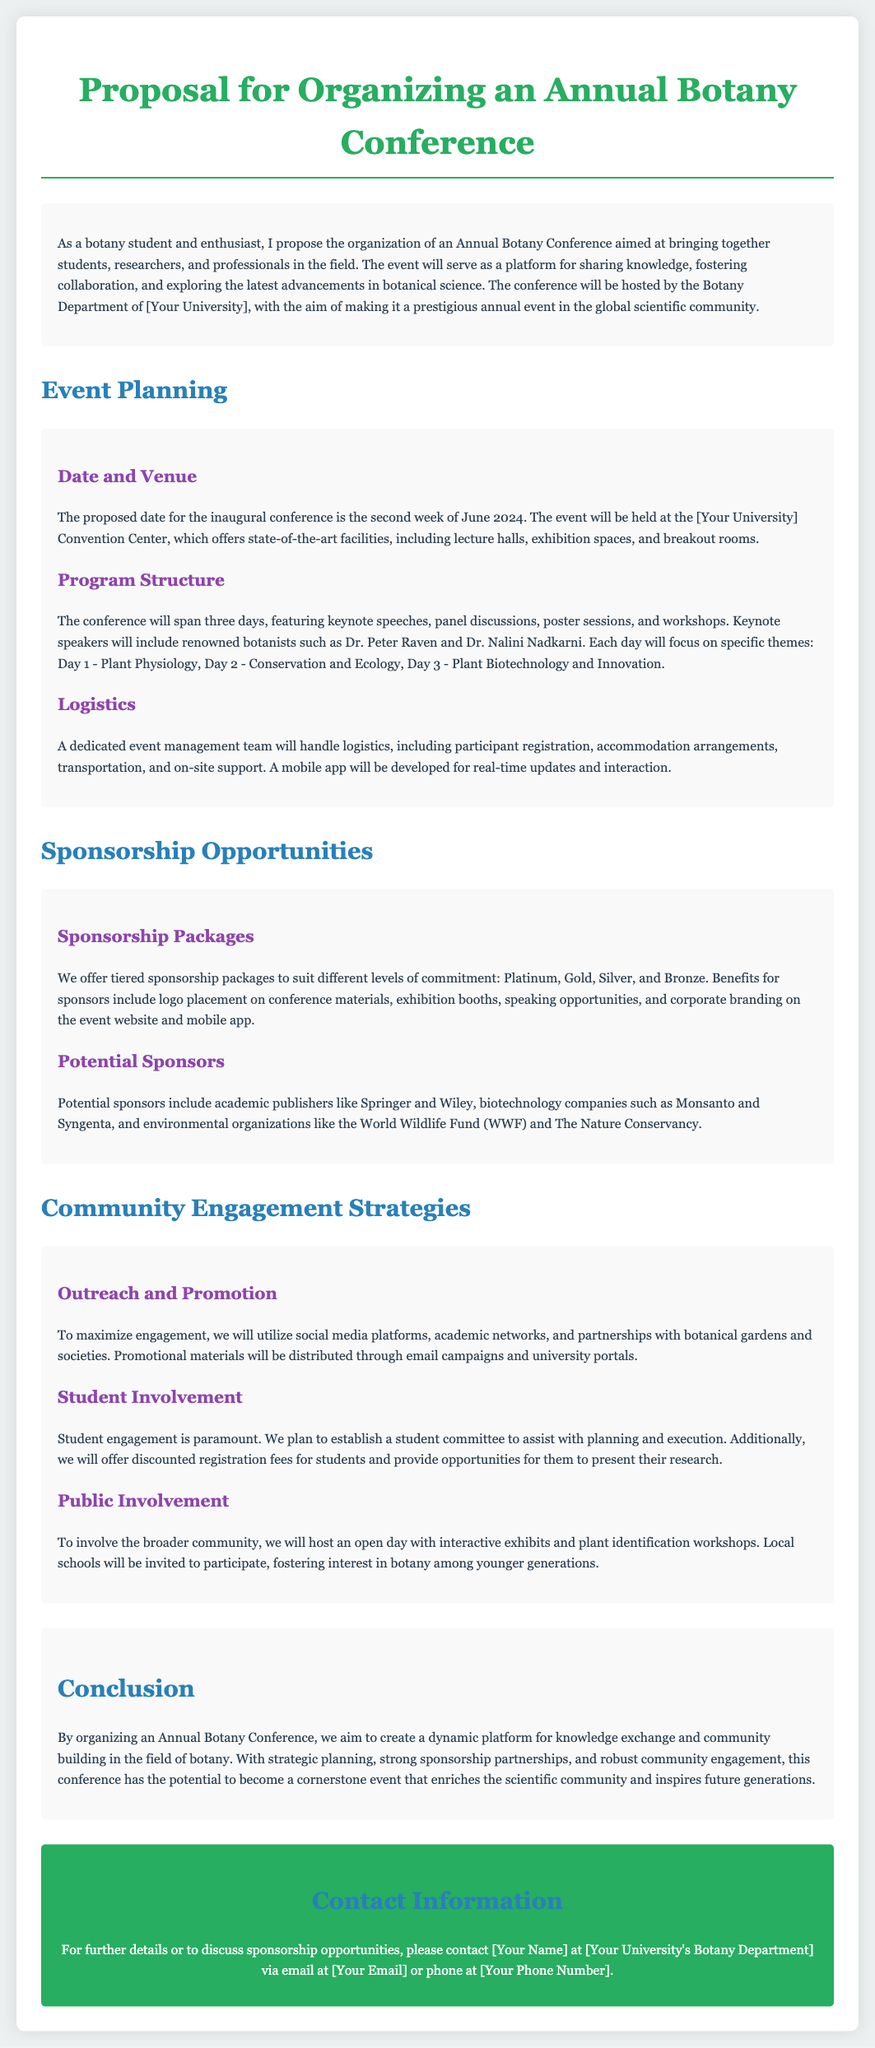What is the proposed date for the conference? The document states that the proposed date for the inaugural conference is the second week of June 2024.
Answer: second week of June 2024 Who are the keynote speakers? Keynote speakers mentioned in the document are Dr. Peter Raven and Dr. Nalini Nadkarni.
Answer: Dr. Peter Raven and Dr. Nalini Nadkarni How many days will the conference span? The document indicates that the conference will span three days.
Answer: three days What are the tiers of sponsorship packages? The document lists sponsorship packages as Platinum, Gold, Silver, and Bronze.
Answer: Platinum, Gold, Silver, and Bronze What community engagement activity will involve local schools? The document describes hosting an open day with interactive exhibits and plant identification workshops to involve local schools.
Answer: open day with interactive exhibits and plant identification workshops What is the main goal of the conference? The proposal aims to create a dynamic platform for knowledge exchange and community building in the field of botany.
Answer: knowledge exchange and community building in the field of botany What will the event management team handle? The event management team will handle logistics such as participant registration, accommodation arrangements, and transportation.
Answer: logistics such as participant registration, accommodation arrangements, and transportation What role will students play in the conference? The document states that student engagement is paramount and a student committee will assist with planning and execution.
Answer: student committee will assist with planning and execution 